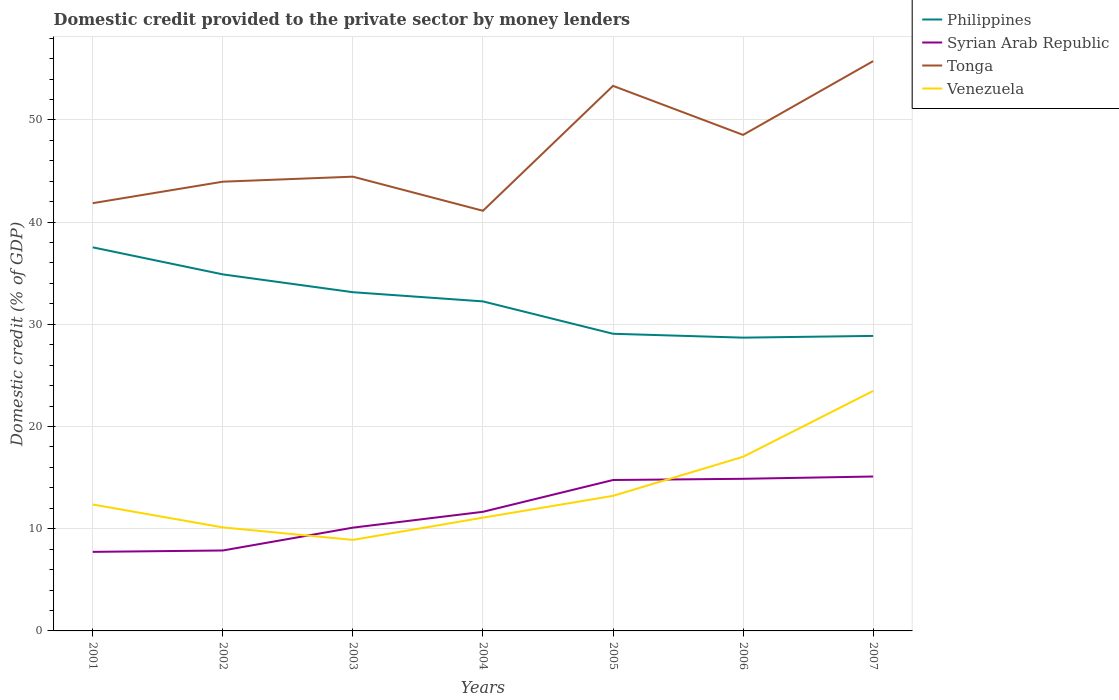Does the line corresponding to Venezuela intersect with the line corresponding to Tonga?
Ensure brevity in your answer.  No. Across all years, what is the maximum domestic credit provided to the private sector by money lenders in Venezuela?
Your answer should be very brief. 8.91. In which year was the domestic credit provided to the private sector by money lenders in Philippines maximum?
Ensure brevity in your answer.  2006. What is the total domestic credit provided to the private sector by money lenders in Tonga in the graph?
Offer a terse response. -6.68. What is the difference between the highest and the second highest domestic credit provided to the private sector by money lenders in Philippines?
Your answer should be compact. 8.84. What is the difference between the highest and the lowest domestic credit provided to the private sector by money lenders in Syrian Arab Republic?
Your answer should be compact. 3. Is the domestic credit provided to the private sector by money lenders in Tonga strictly greater than the domestic credit provided to the private sector by money lenders in Venezuela over the years?
Offer a very short reply. No. How many legend labels are there?
Your answer should be very brief. 4. What is the title of the graph?
Provide a short and direct response. Domestic credit provided to the private sector by money lenders. What is the label or title of the X-axis?
Provide a short and direct response. Years. What is the label or title of the Y-axis?
Give a very brief answer. Domestic credit (% of GDP). What is the Domestic credit (% of GDP) in Philippines in 2001?
Offer a very short reply. 37.53. What is the Domestic credit (% of GDP) of Syrian Arab Republic in 2001?
Your response must be concise. 7.74. What is the Domestic credit (% of GDP) of Tonga in 2001?
Your answer should be compact. 41.85. What is the Domestic credit (% of GDP) in Venezuela in 2001?
Provide a short and direct response. 12.37. What is the Domestic credit (% of GDP) in Philippines in 2002?
Keep it short and to the point. 34.88. What is the Domestic credit (% of GDP) of Syrian Arab Republic in 2002?
Provide a succinct answer. 7.87. What is the Domestic credit (% of GDP) of Tonga in 2002?
Make the answer very short. 43.95. What is the Domestic credit (% of GDP) in Venezuela in 2002?
Your response must be concise. 10.13. What is the Domestic credit (% of GDP) in Philippines in 2003?
Give a very brief answer. 33.14. What is the Domestic credit (% of GDP) of Syrian Arab Republic in 2003?
Ensure brevity in your answer.  10.1. What is the Domestic credit (% of GDP) in Tonga in 2003?
Offer a very short reply. 44.44. What is the Domestic credit (% of GDP) of Venezuela in 2003?
Offer a very short reply. 8.91. What is the Domestic credit (% of GDP) of Philippines in 2004?
Your response must be concise. 32.24. What is the Domestic credit (% of GDP) of Syrian Arab Republic in 2004?
Provide a short and direct response. 11.65. What is the Domestic credit (% of GDP) of Tonga in 2004?
Ensure brevity in your answer.  41.11. What is the Domestic credit (% of GDP) of Venezuela in 2004?
Your answer should be compact. 11.08. What is the Domestic credit (% of GDP) of Philippines in 2005?
Ensure brevity in your answer.  29.07. What is the Domestic credit (% of GDP) of Syrian Arab Republic in 2005?
Your response must be concise. 14.76. What is the Domestic credit (% of GDP) of Tonga in 2005?
Ensure brevity in your answer.  53.33. What is the Domestic credit (% of GDP) of Venezuela in 2005?
Keep it short and to the point. 13.21. What is the Domestic credit (% of GDP) in Philippines in 2006?
Provide a short and direct response. 28.69. What is the Domestic credit (% of GDP) in Syrian Arab Republic in 2006?
Keep it short and to the point. 14.88. What is the Domestic credit (% of GDP) in Tonga in 2006?
Keep it short and to the point. 48.53. What is the Domestic credit (% of GDP) in Venezuela in 2006?
Give a very brief answer. 17.04. What is the Domestic credit (% of GDP) in Philippines in 2007?
Your response must be concise. 28.86. What is the Domestic credit (% of GDP) in Syrian Arab Republic in 2007?
Your response must be concise. 15.11. What is the Domestic credit (% of GDP) of Tonga in 2007?
Offer a terse response. 55.75. What is the Domestic credit (% of GDP) of Venezuela in 2007?
Offer a terse response. 23.48. Across all years, what is the maximum Domestic credit (% of GDP) in Philippines?
Provide a short and direct response. 37.53. Across all years, what is the maximum Domestic credit (% of GDP) in Syrian Arab Republic?
Offer a terse response. 15.11. Across all years, what is the maximum Domestic credit (% of GDP) of Tonga?
Provide a short and direct response. 55.75. Across all years, what is the maximum Domestic credit (% of GDP) in Venezuela?
Give a very brief answer. 23.48. Across all years, what is the minimum Domestic credit (% of GDP) in Philippines?
Your answer should be compact. 28.69. Across all years, what is the minimum Domestic credit (% of GDP) in Syrian Arab Republic?
Offer a terse response. 7.74. Across all years, what is the minimum Domestic credit (% of GDP) of Tonga?
Give a very brief answer. 41.11. Across all years, what is the minimum Domestic credit (% of GDP) in Venezuela?
Provide a short and direct response. 8.91. What is the total Domestic credit (% of GDP) of Philippines in the graph?
Your response must be concise. 224.43. What is the total Domestic credit (% of GDP) in Syrian Arab Republic in the graph?
Provide a short and direct response. 82.12. What is the total Domestic credit (% of GDP) of Tonga in the graph?
Provide a short and direct response. 328.96. What is the total Domestic credit (% of GDP) in Venezuela in the graph?
Your answer should be very brief. 96.22. What is the difference between the Domestic credit (% of GDP) in Philippines in 2001 and that in 2002?
Keep it short and to the point. 2.65. What is the difference between the Domestic credit (% of GDP) in Syrian Arab Republic in 2001 and that in 2002?
Provide a succinct answer. -0.14. What is the difference between the Domestic credit (% of GDP) in Tonga in 2001 and that in 2002?
Offer a very short reply. -2.1. What is the difference between the Domestic credit (% of GDP) of Venezuela in 2001 and that in 2002?
Offer a terse response. 2.24. What is the difference between the Domestic credit (% of GDP) in Philippines in 2001 and that in 2003?
Make the answer very short. 4.39. What is the difference between the Domestic credit (% of GDP) in Syrian Arab Republic in 2001 and that in 2003?
Your response must be concise. -2.37. What is the difference between the Domestic credit (% of GDP) in Tonga in 2001 and that in 2003?
Make the answer very short. -2.59. What is the difference between the Domestic credit (% of GDP) of Venezuela in 2001 and that in 2003?
Provide a succinct answer. 3.46. What is the difference between the Domestic credit (% of GDP) in Philippines in 2001 and that in 2004?
Keep it short and to the point. 5.29. What is the difference between the Domestic credit (% of GDP) in Syrian Arab Republic in 2001 and that in 2004?
Provide a short and direct response. -3.92. What is the difference between the Domestic credit (% of GDP) of Tonga in 2001 and that in 2004?
Give a very brief answer. 0.74. What is the difference between the Domestic credit (% of GDP) of Venezuela in 2001 and that in 2004?
Make the answer very short. 1.29. What is the difference between the Domestic credit (% of GDP) in Philippines in 2001 and that in 2005?
Provide a succinct answer. 8.46. What is the difference between the Domestic credit (% of GDP) of Syrian Arab Republic in 2001 and that in 2005?
Provide a short and direct response. -7.03. What is the difference between the Domestic credit (% of GDP) of Tonga in 2001 and that in 2005?
Your answer should be very brief. -11.48. What is the difference between the Domestic credit (% of GDP) of Venezuela in 2001 and that in 2005?
Give a very brief answer. -0.84. What is the difference between the Domestic credit (% of GDP) in Philippines in 2001 and that in 2006?
Make the answer very short. 8.84. What is the difference between the Domestic credit (% of GDP) in Syrian Arab Republic in 2001 and that in 2006?
Provide a succinct answer. -7.15. What is the difference between the Domestic credit (% of GDP) in Tonga in 2001 and that in 2006?
Your answer should be compact. -6.68. What is the difference between the Domestic credit (% of GDP) of Venezuela in 2001 and that in 2006?
Give a very brief answer. -4.67. What is the difference between the Domestic credit (% of GDP) of Philippines in 2001 and that in 2007?
Offer a terse response. 8.67. What is the difference between the Domestic credit (% of GDP) of Syrian Arab Republic in 2001 and that in 2007?
Your response must be concise. -7.37. What is the difference between the Domestic credit (% of GDP) of Tonga in 2001 and that in 2007?
Keep it short and to the point. -13.9. What is the difference between the Domestic credit (% of GDP) of Venezuela in 2001 and that in 2007?
Give a very brief answer. -11.11. What is the difference between the Domestic credit (% of GDP) in Philippines in 2002 and that in 2003?
Keep it short and to the point. 1.74. What is the difference between the Domestic credit (% of GDP) of Syrian Arab Republic in 2002 and that in 2003?
Your answer should be very brief. -2.23. What is the difference between the Domestic credit (% of GDP) in Tonga in 2002 and that in 2003?
Keep it short and to the point. -0.49. What is the difference between the Domestic credit (% of GDP) in Venezuela in 2002 and that in 2003?
Keep it short and to the point. 1.22. What is the difference between the Domestic credit (% of GDP) in Philippines in 2002 and that in 2004?
Keep it short and to the point. 2.64. What is the difference between the Domestic credit (% of GDP) in Syrian Arab Republic in 2002 and that in 2004?
Ensure brevity in your answer.  -3.78. What is the difference between the Domestic credit (% of GDP) of Tonga in 2002 and that in 2004?
Offer a terse response. 2.85. What is the difference between the Domestic credit (% of GDP) of Venezuela in 2002 and that in 2004?
Your response must be concise. -0.95. What is the difference between the Domestic credit (% of GDP) in Philippines in 2002 and that in 2005?
Your response must be concise. 5.81. What is the difference between the Domestic credit (% of GDP) of Syrian Arab Republic in 2002 and that in 2005?
Your response must be concise. -6.89. What is the difference between the Domestic credit (% of GDP) in Tonga in 2002 and that in 2005?
Provide a succinct answer. -9.38. What is the difference between the Domestic credit (% of GDP) of Venezuela in 2002 and that in 2005?
Offer a very short reply. -3.09. What is the difference between the Domestic credit (% of GDP) of Philippines in 2002 and that in 2006?
Your response must be concise. 6.19. What is the difference between the Domestic credit (% of GDP) in Syrian Arab Republic in 2002 and that in 2006?
Your answer should be compact. -7.01. What is the difference between the Domestic credit (% of GDP) in Tonga in 2002 and that in 2006?
Give a very brief answer. -4.58. What is the difference between the Domestic credit (% of GDP) in Venezuela in 2002 and that in 2006?
Offer a very short reply. -6.91. What is the difference between the Domestic credit (% of GDP) of Philippines in 2002 and that in 2007?
Provide a short and direct response. 6.02. What is the difference between the Domestic credit (% of GDP) of Syrian Arab Republic in 2002 and that in 2007?
Provide a short and direct response. -7.24. What is the difference between the Domestic credit (% of GDP) in Tonga in 2002 and that in 2007?
Your answer should be compact. -11.8. What is the difference between the Domestic credit (% of GDP) in Venezuela in 2002 and that in 2007?
Your answer should be compact. -13.35. What is the difference between the Domestic credit (% of GDP) of Philippines in 2003 and that in 2004?
Give a very brief answer. 0.9. What is the difference between the Domestic credit (% of GDP) in Syrian Arab Republic in 2003 and that in 2004?
Make the answer very short. -1.55. What is the difference between the Domestic credit (% of GDP) in Tonga in 2003 and that in 2004?
Offer a very short reply. 3.34. What is the difference between the Domestic credit (% of GDP) of Venezuela in 2003 and that in 2004?
Offer a very short reply. -2.18. What is the difference between the Domestic credit (% of GDP) in Philippines in 2003 and that in 2005?
Keep it short and to the point. 4.07. What is the difference between the Domestic credit (% of GDP) of Syrian Arab Republic in 2003 and that in 2005?
Provide a short and direct response. -4.66. What is the difference between the Domestic credit (% of GDP) in Tonga in 2003 and that in 2005?
Provide a short and direct response. -8.88. What is the difference between the Domestic credit (% of GDP) in Venezuela in 2003 and that in 2005?
Make the answer very short. -4.31. What is the difference between the Domestic credit (% of GDP) of Philippines in 2003 and that in 2006?
Ensure brevity in your answer.  4.45. What is the difference between the Domestic credit (% of GDP) of Syrian Arab Republic in 2003 and that in 2006?
Provide a succinct answer. -4.78. What is the difference between the Domestic credit (% of GDP) in Tonga in 2003 and that in 2006?
Provide a succinct answer. -4.09. What is the difference between the Domestic credit (% of GDP) of Venezuela in 2003 and that in 2006?
Give a very brief answer. -8.13. What is the difference between the Domestic credit (% of GDP) in Philippines in 2003 and that in 2007?
Offer a terse response. 4.28. What is the difference between the Domestic credit (% of GDP) in Syrian Arab Republic in 2003 and that in 2007?
Make the answer very short. -5. What is the difference between the Domestic credit (% of GDP) of Tonga in 2003 and that in 2007?
Provide a short and direct response. -11.31. What is the difference between the Domestic credit (% of GDP) in Venezuela in 2003 and that in 2007?
Provide a short and direct response. -14.57. What is the difference between the Domestic credit (% of GDP) of Philippines in 2004 and that in 2005?
Keep it short and to the point. 3.17. What is the difference between the Domestic credit (% of GDP) in Syrian Arab Republic in 2004 and that in 2005?
Offer a very short reply. -3.11. What is the difference between the Domestic credit (% of GDP) in Tonga in 2004 and that in 2005?
Your answer should be compact. -12.22. What is the difference between the Domestic credit (% of GDP) of Venezuela in 2004 and that in 2005?
Provide a succinct answer. -2.13. What is the difference between the Domestic credit (% of GDP) in Philippines in 2004 and that in 2006?
Provide a succinct answer. 3.55. What is the difference between the Domestic credit (% of GDP) of Syrian Arab Republic in 2004 and that in 2006?
Ensure brevity in your answer.  -3.23. What is the difference between the Domestic credit (% of GDP) of Tonga in 2004 and that in 2006?
Give a very brief answer. -7.42. What is the difference between the Domestic credit (% of GDP) of Venezuela in 2004 and that in 2006?
Give a very brief answer. -5.96. What is the difference between the Domestic credit (% of GDP) in Philippines in 2004 and that in 2007?
Give a very brief answer. 3.38. What is the difference between the Domestic credit (% of GDP) in Syrian Arab Republic in 2004 and that in 2007?
Make the answer very short. -3.45. What is the difference between the Domestic credit (% of GDP) in Tonga in 2004 and that in 2007?
Provide a succinct answer. -14.64. What is the difference between the Domestic credit (% of GDP) of Venezuela in 2004 and that in 2007?
Keep it short and to the point. -12.4. What is the difference between the Domestic credit (% of GDP) of Philippines in 2005 and that in 2006?
Your answer should be very brief. 0.38. What is the difference between the Domestic credit (% of GDP) of Syrian Arab Republic in 2005 and that in 2006?
Your answer should be compact. -0.12. What is the difference between the Domestic credit (% of GDP) in Tonga in 2005 and that in 2006?
Your answer should be very brief. 4.8. What is the difference between the Domestic credit (% of GDP) of Venezuela in 2005 and that in 2006?
Provide a succinct answer. -3.82. What is the difference between the Domestic credit (% of GDP) in Philippines in 2005 and that in 2007?
Provide a short and direct response. 0.21. What is the difference between the Domestic credit (% of GDP) in Syrian Arab Republic in 2005 and that in 2007?
Keep it short and to the point. -0.34. What is the difference between the Domestic credit (% of GDP) of Tonga in 2005 and that in 2007?
Your answer should be compact. -2.42. What is the difference between the Domestic credit (% of GDP) in Venezuela in 2005 and that in 2007?
Provide a short and direct response. -10.27. What is the difference between the Domestic credit (% of GDP) of Philippines in 2006 and that in 2007?
Your response must be concise. -0.17. What is the difference between the Domestic credit (% of GDP) of Syrian Arab Republic in 2006 and that in 2007?
Provide a succinct answer. -0.22. What is the difference between the Domestic credit (% of GDP) of Tonga in 2006 and that in 2007?
Provide a succinct answer. -7.22. What is the difference between the Domestic credit (% of GDP) in Venezuela in 2006 and that in 2007?
Offer a very short reply. -6.44. What is the difference between the Domestic credit (% of GDP) of Philippines in 2001 and the Domestic credit (% of GDP) of Syrian Arab Republic in 2002?
Your response must be concise. 29.66. What is the difference between the Domestic credit (% of GDP) in Philippines in 2001 and the Domestic credit (% of GDP) in Tonga in 2002?
Your answer should be very brief. -6.42. What is the difference between the Domestic credit (% of GDP) of Philippines in 2001 and the Domestic credit (% of GDP) of Venezuela in 2002?
Keep it short and to the point. 27.4. What is the difference between the Domestic credit (% of GDP) in Syrian Arab Republic in 2001 and the Domestic credit (% of GDP) in Tonga in 2002?
Offer a very short reply. -36.22. What is the difference between the Domestic credit (% of GDP) of Syrian Arab Republic in 2001 and the Domestic credit (% of GDP) of Venezuela in 2002?
Provide a succinct answer. -2.39. What is the difference between the Domestic credit (% of GDP) in Tonga in 2001 and the Domestic credit (% of GDP) in Venezuela in 2002?
Provide a succinct answer. 31.72. What is the difference between the Domestic credit (% of GDP) in Philippines in 2001 and the Domestic credit (% of GDP) in Syrian Arab Republic in 2003?
Provide a succinct answer. 27.43. What is the difference between the Domestic credit (% of GDP) of Philippines in 2001 and the Domestic credit (% of GDP) of Tonga in 2003?
Your answer should be very brief. -6.91. What is the difference between the Domestic credit (% of GDP) of Philippines in 2001 and the Domestic credit (% of GDP) of Venezuela in 2003?
Your answer should be compact. 28.62. What is the difference between the Domestic credit (% of GDP) of Syrian Arab Republic in 2001 and the Domestic credit (% of GDP) of Tonga in 2003?
Provide a succinct answer. -36.71. What is the difference between the Domestic credit (% of GDP) in Syrian Arab Republic in 2001 and the Domestic credit (% of GDP) in Venezuela in 2003?
Provide a short and direct response. -1.17. What is the difference between the Domestic credit (% of GDP) of Tonga in 2001 and the Domestic credit (% of GDP) of Venezuela in 2003?
Give a very brief answer. 32.95. What is the difference between the Domestic credit (% of GDP) in Philippines in 2001 and the Domestic credit (% of GDP) in Syrian Arab Republic in 2004?
Your answer should be very brief. 25.88. What is the difference between the Domestic credit (% of GDP) of Philippines in 2001 and the Domestic credit (% of GDP) of Tonga in 2004?
Your response must be concise. -3.58. What is the difference between the Domestic credit (% of GDP) of Philippines in 2001 and the Domestic credit (% of GDP) of Venezuela in 2004?
Your answer should be compact. 26.45. What is the difference between the Domestic credit (% of GDP) in Syrian Arab Republic in 2001 and the Domestic credit (% of GDP) in Tonga in 2004?
Provide a short and direct response. -33.37. What is the difference between the Domestic credit (% of GDP) in Syrian Arab Republic in 2001 and the Domestic credit (% of GDP) in Venezuela in 2004?
Provide a short and direct response. -3.35. What is the difference between the Domestic credit (% of GDP) of Tonga in 2001 and the Domestic credit (% of GDP) of Venezuela in 2004?
Your answer should be very brief. 30.77. What is the difference between the Domestic credit (% of GDP) in Philippines in 2001 and the Domestic credit (% of GDP) in Syrian Arab Republic in 2005?
Your answer should be compact. 22.77. What is the difference between the Domestic credit (% of GDP) of Philippines in 2001 and the Domestic credit (% of GDP) of Tonga in 2005?
Provide a succinct answer. -15.8. What is the difference between the Domestic credit (% of GDP) in Philippines in 2001 and the Domestic credit (% of GDP) in Venezuela in 2005?
Provide a succinct answer. 24.31. What is the difference between the Domestic credit (% of GDP) in Syrian Arab Republic in 2001 and the Domestic credit (% of GDP) in Tonga in 2005?
Your response must be concise. -45.59. What is the difference between the Domestic credit (% of GDP) in Syrian Arab Republic in 2001 and the Domestic credit (% of GDP) in Venezuela in 2005?
Offer a very short reply. -5.48. What is the difference between the Domestic credit (% of GDP) of Tonga in 2001 and the Domestic credit (% of GDP) of Venezuela in 2005?
Provide a succinct answer. 28.64. What is the difference between the Domestic credit (% of GDP) in Philippines in 2001 and the Domestic credit (% of GDP) in Syrian Arab Republic in 2006?
Your answer should be very brief. 22.65. What is the difference between the Domestic credit (% of GDP) in Philippines in 2001 and the Domestic credit (% of GDP) in Tonga in 2006?
Offer a very short reply. -11. What is the difference between the Domestic credit (% of GDP) of Philippines in 2001 and the Domestic credit (% of GDP) of Venezuela in 2006?
Your answer should be compact. 20.49. What is the difference between the Domestic credit (% of GDP) of Syrian Arab Republic in 2001 and the Domestic credit (% of GDP) of Tonga in 2006?
Make the answer very short. -40.8. What is the difference between the Domestic credit (% of GDP) of Syrian Arab Republic in 2001 and the Domestic credit (% of GDP) of Venezuela in 2006?
Offer a very short reply. -9.3. What is the difference between the Domestic credit (% of GDP) in Tonga in 2001 and the Domestic credit (% of GDP) in Venezuela in 2006?
Provide a succinct answer. 24.81. What is the difference between the Domestic credit (% of GDP) in Philippines in 2001 and the Domestic credit (% of GDP) in Syrian Arab Republic in 2007?
Your answer should be very brief. 22.42. What is the difference between the Domestic credit (% of GDP) in Philippines in 2001 and the Domestic credit (% of GDP) in Tonga in 2007?
Make the answer very short. -18.22. What is the difference between the Domestic credit (% of GDP) in Philippines in 2001 and the Domestic credit (% of GDP) in Venezuela in 2007?
Give a very brief answer. 14.05. What is the difference between the Domestic credit (% of GDP) of Syrian Arab Republic in 2001 and the Domestic credit (% of GDP) of Tonga in 2007?
Provide a short and direct response. -48.02. What is the difference between the Domestic credit (% of GDP) of Syrian Arab Republic in 2001 and the Domestic credit (% of GDP) of Venezuela in 2007?
Offer a terse response. -15.75. What is the difference between the Domestic credit (% of GDP) of Tonga in 2001 and the Domestic credit (% of GDP) of Venezuela in 2007?
Provide a succinct answer. 18.37. What is the difference between the Domestic credit (% of GDP) in Philippines in 2002 and the Domestic credit (% of GDP) in Syrian Arab Republic in 2003?
Provide a succinct answer. 24.78. What is the difference between the Domestic credit (% of GDP) in Philippines in 2002 and the Domestic credit (% of GDP) in Tonga in 2003?
Provide a succinct answer. -9.56. What is the difference between the Domestic credit (% of GDP) in Philippines in 2002 and the Domestic credit (% of GDP) in Venezuela in 2003?
Offer a terse response. 25.98. What is the difference between the Domestic credit (% of GDP) of Syrian Arab Republic in 2002 and the Domestic credit (% of GDP) of Tonga in 2003?
Provide a succinct answer. -36.57. What is the difference between the Domestic credit (% of GDP) of Syrian Arab Republic in 2002 and the Domestic credit (% of GDP) of Venezuela in 2003?
Provide a succinct answer. -1.04. What is the difference between the Domestic credit (% of GDP) in Tonga in 2002 and the Domestic credit (% of GDP) in Venezuela in 2003?
Offer a terse response. 35.05. What is the difference between the Domestic credit (% of GDP) of Philippines in 2002 and the Domestic credit (% of GDP) of Syrian Arab Republic in 2004?
Your answer should be very brief. 23.23. What is the difference between the Domestic credit (% of GDP) of Philippines in 2002 and the Domestic credit (% of GDP) of Tonga in 2004?
Offer a very short reply. -6.22. What is the difference between the Domestic credit (% of GDP) of Philippines in 2002 and the Domestic credit (% of GDP) of Venezuela in 2004?
Provide a short and direct response. 23.8. What is the difference between the Domestic credit (% of GDP) in Syrian Arab Republic in 2002 and the Domestic credit (% of GDP) in Tonga in 2004?
Offer a very short reply. -33.24. What is the difference between the Domestic credit (% of GDP) in Syrian Arab Republic in 2002 and the Domestic credit (% of GDP) in Venezuela in 2004?
Ensure brevity in your answer.  -3.21. What is the difference between the Domestic credit (% of GDP) of Tonga in 2002 and the Domestic credit (% of GDP) of Venezuela in 2004?
Provide a succinct answer. 32.87. What is the difference between the Domestic credit (% of GDP) in Philippines in 2002 and the Domestic credit (% of GDP) in Syrian Arab Republic in 2005?
Your answer should be compact. 20.12. What is the difference between the Domestic credit (% of GDP) in Philippines in 2002 and the Domestic credit (% of GDP) in Tonga in 2005?
Give a very brief answer. -18.44. What is the difference between the Domestic credit (% of GDP) of Philippines in 2002 and the Domestic credit (% of GDP) of Venezuela in 2005?
Provide a succinct answer. 21.67. What is the difference between the Domestic credit (% of GDP) in Syrian Arab Republic in 2002 and the Domestic credit (% of GDP) in Tonga in 2005?
Provide a succinct answer. -45.46. What is the difference between the Domestic credit (% of GDP) in Syrian Arab Republic in 2002 and the Domestic credit (% of GDP) in Venezuela in 2005?
Your answer should be compact. -5.34. What is the difference between the Domestic credit (% of GDP) in Tonga in 2002 and the Domestic credit (% of GDP) in Venezuela in 2005?
Ensure brevity in your answer.  30.74. What is the difference between the Domestic credit (% of GDP) of Philippines in 2002 and the Domestic credit (% of GDP) of Syrian Arab Republic in 2006?
Keep it short and to the point. 20. What is the difference between the Domestic credit (% of GDP) of Philippines in 2002 and the Domestic credit (% of GDP) of Tonga in 2006?
Your answer should be compact. -13.65. What is the difference between the Domestic credit (% of GDP) in Philippines in 2002 and the Domestic credit (% of GDP) in Venezuela in 2006?
Offer a very short reply. 17.85. What is the difference between the Domestic credit (% of GDP) in Syrian Arab Republic in 2002 and the Domestic credit (% of GDP) in Tonga in 2006?
Ensure brevity in your answer.  -40.66. What is the difference between the Domestic credit (% of GDP) in Syrian Arab Republic in 2002 and the Domestic credit (% of GDP) in Venezuela in 2006?
Keep it short and to the point. -9.17. What is the difference between the Domestic credit (% of GDP) of Tonga in 2002 and the Domestic credit (% of GDP) of Venezuela in 2006?
Provide a succinct answer. 26.92. What is the difference between the Domestic credit (% of GDP) of Philippines in 2002 and the Domestic credit (% of GDP) of Syrian Arab Republic in 2007?
Your answer should be very brief. 19.78. What is the difference between the Domestic credit (% of GDP) of Philippines in 2002 and the Domestic credit (% of GDP) of Tonga in 2007?
Give a very brief answer. -20.87. What is the difference between the Domestic credit (% of GDP) of Philippines in 2002 and the Domestic credit (% of GDP) of Venezuela in 2007?
Your response must be concise. 11.4. What is the difference between the Domestic credit (% of GDP) in Syrian Arab Republic in 2002 and the Domestic credit (% of GDP) in Tonga in 2007?
Offer a terse response. -47.88. What is the difference between the Domestic credit (% of GDP) of Syrian Arab Republic in 2002 and the Domestic credit (% of GDP) of Venezuela in 2007?
Ensure brevity in your answer.  -15.61. What is the difference between the Domestic credit (% of GDP) of Tonga in 2002 and the Domestic credit (% of GDP) of Venezuela in 2007?
Your answer should be very brief. 20.47. What is the difference between the Domestic credit (% of GDP) in Philippines in 2003 and the Domestic credit (% of GDP) in Syrian Arab Republic in 2004?
Make the answer very short. 21.49. What is the difference between the Domestic credit (% of GDP) of Philippines in 2003 and the Domestic credit (% of GDP) of Tonga in 2004?
Give a very brief answer. -7.97. What is the difference between the Domestic credit (% of GDP) in Philippines in 2003 and the Domestic credit (% of GDP) in Venezuela in 2004?
Your answer should be compact. 22.06. What is the difference between the Domestic credit (% of GDP) in Syrian Arab Republic in 2003 and the Domestic credit (% of GDP) in Tonga in 2004?
Provide a succinct answer. -31. What is the difference between the Domestic credit (% of GDP) of Syrian Arab Republic in 2003 and the Domestic credit (% of GDP) of Venezuela in 2004?
Your response must be concise. -0.98. What is the difference between the Domestic credit (% of GDP) of Tonga in 2003 and the Domestic credit (% of GDP) of Venezuela in 2004?
Keep it short and to the point. 33.36. What is the difference between the Domestic credit (% of GDP) of Philippines in 2003 and the Domestic credit (% of GDP) of Syrian Arab Republic in 2005?
Make the answer very short. 18.38. What is the difference between the Domestic credit (% of GDP) in Philippines in 2003 and the Domestic credit (% of GDP) in Tonga in 2005?
Your response must be concise. -20.19. What is the difference between the Domestic credit (% of GDP) in Philippines in 2003 and the Domestic credit (% of GDP) in Venezuela in 2005?
Offer a very short reply. 19.93. What is the difference between the Domestic credit (% of GDP) in Syrian Arab Republic in 2003 and the Domestic credit (% of GDP) in Tonga in 2005?
Keep it short and to the point. -43.22. What is the difference between the Domestic credit (% of GDP) of Syrian Arab Republic in 2003 and the Domestic credit (% of GDP) of Venezuela in 2005?
Your response must be concise. -3.11. What is the difference between the Domestic credit (% of GDP) of Tonga in 2003 and the Domestic credit (% of GDP) of Venezuela in 2005?
Keep it short and to the point. 31.23. What is the difference between the Domestic credit (% of GDP) of Philippines in 2003 and the Domestic credit (% of GDP) of Syrian Arab Republic in 2006?
Keep it short and to the point. 18.26. What is the difference between the Domestic credit (% of GDP) of Philippines in 2003 and the Domestic credit (% of GDP) of Tonga in 2006?
Ensure brevity in your answer.  -15.39. What is the difference between the Domestic credit (% of GDP) of Philippines in 2003 and the Domestic credit (% of GDP) of Venezuela in 2006?
Your response must be concise. 16.1. What is the difference between the Domestic credit (% of GDP) of Syrian Arab Republic in 2003 and the Domestic credit (% of GDP) of Tonga in 2006?
Your response must be concise. -38.43. What is the difference between the Domestic credit (% of GDP) of Syrian Arab Republic in 2003 and the Domestic credit (% of GDP) of Venezuela in 2006?
Your response must be concise. -6.93. What is the difference between the Domestic credit (% of GDP) of Tonga in 2003 and the Domestic credit (% of GDP) of Venezuela in 2006?
Keep it short and to the point. 27.41. What is the difference between the Domestic credit (% of GDP) of Philippines in 2003 and the Domestic credit (% of GDP) of Syrian Arab Republic in 2007?
Provide a short and direct response. 18.03. What is the difference between the Domestic credit (% of GDP) of Philippines in 2003 and the Domestic credit (% of GDP) of Tonga in 2007?
Provide a succinct answer. -22.61. What is the difference between the Domestic credit (% of GDP) in Philippines in 2003 and the Domestic credit (% of GDP) in Venezuela in 2007?
Make the answer very short. 9.66. What is the difference between the Domestic credit (% of GDP) of Syrian Arab Republic in 2003 and the Domestic credit (% of GDP) of Tonga in 2007?
Provide a succinct answer. -45.65. What is the difference between the Domestic credit (% of GDP) of Syrian Arab Republic in 2003 and the Domestic credit (% of GDP) of Venezuela in 2007?
Your response must be concise. -13.38. What is the difference between the Domestic credit (% of GDP) in Tonga in 2003 and the Domestic credit (% of GDP) in Venezuela in 2007?
Provide a succinct answer. 20.96. What is the difference between the Domestic credit (% of GDP) of Philippines in 2004 and the Domestic credit (% of GDP) of Syrian Arab Republic in 2005?
Keep it short and to the point. 17.48. What is the difference between the Domestic credit (% of GDP) in Philippines in 2004 and the Domestic credit (% of GDP) in Tonga in 2005?
Provide a succinct answer. -21.09. What is the difference between the Domestic credit (% of GDP) in Philippines in 2004 and the Domestic credit (% of GDP) in Venezuela in 2005?
Keep it short and to the point. 19.03. What is the difference between the Domestic credit (% of GDP) of Syrian Arab Republic in 2004 and the Domestic credit (% of GDP) of Tonga in 2005?
Your answer should be very brief. -41.67. What is the difference between the Domestic credit (% of GDP) in Syrian Arab Republic in 2004 and the Domestic credit (% of GDP) in Venezuela in 2005?
Offer a terse response. -1.56. What is the difference between the Domestic credit (% of GDP) of Tonga in 2004 and the Domestic credit (% of GDP) of Venezuela in 2005?
Offer a terse response. 27.89. What is the difference between the Domestic credit (% of GDP) of Philippines in 2004 and the Domestic credit (% of GDP) of Syrian Arab Republic in 2006?
Provide a short and direct response. 17.36. What is the difference between the Domestic credit (% of GDP) of Philippines in 2004 and the Domestic credit (% of GDP) of Tonga in 2006?
Keep it short and to the point. -16.29. What is the difference between the Domestic credit (% of GDP) of Philippines in 2004 and the Domestic credit (% of GDP) of Venezuela in 2006?
Offer a very short reply. 15.2. What is the difference between the Domestic credit (% of GDP) of Syrian Arab Republic in 2004 and the Domestic credit (% of GDP) of Tonga in 2006?
Offer a very short reply. -36.88. What is the difference between the Domestic credit (% of GDP) of Syrian Arab Republic in 2004 and the Domestic credit (% of GDP) of Venezuela in 2006?
Your answer should be compact. -5.38. What is the difference between the Domestic credit (% of GDP) of Tonga in 2004 and the Domestic credit (% of GDP) of Venezuela in 2006?
Your answer should be very brief. 24.07. What is the difference between the Domestic credit (% of GDP) in Philippines in 2004 and the Domestic credit (% of GDP) in Syrian Arab Republic in 2007?
Offer a terse response. 17.13. What is the difference between the Domestic credit (% of GDP) of Philippines in 2004 and the Domestic credit (% of GDP) of Tonga in 2007?
Give a very brief answer. -23.51. What is the difference between the Domestic credit (% of GDP) of Philippines in 2004 and the Domestic credit (% of GDP) of Venezuela in 2007?
Offer a very short reply. 8.76. What is the difference between the Domestic credit (% of GDP) of Syrian Arab Republic in 2004 and the Domestic credit (% of GDP) of Tonga in 2007?
Offer a very short reply. -44.1. What is the difference between the Domestic credit (% of GDP) in Syrian Arab Republic in 2004 and the Domestic credit (% of GDP) in Venezuela in 2007?
Provide a succinct answer. -11.83. What is the difference between the Domestic credit (% of GDP) in Tonga in 2004 and the Domestic credit (% of GDP) in Venezuela in 2007?
Ensure brevity in your answer.  17.63. What is the difference between the Domestic credit (% of GDP) of Philippines in 2005 and the Domestic credit (% of GDP) of Syrian Arab Republic in 2006?
Give a very brief answer. 14.19. What is the difference between the Domestic credit (% of GDP) of Philippines in 2005 and the Domestic credit (% of GDP) of Tonga in 2006?
Your answer should be very brief. -19.46. What is the difference between the Domestic credit (% of GDP) of Philippines in 2005 and the Domestic credit (% of GDP) of Venezuela in 2006?
Keep it short and to the point. 12.04. What is the difference between the Domestic credit (% of GDP) of Syrian Arab Republic in 2005 and the Domestic credit (% of GDP) of Tonga in 2006?
Ensure brevity in your answer.  -33.77. What is the difference between the Domestic credit (% of GDP) in Syrian Arab Republic in 2005 and the Domestic credit (% of GDP) in Venezuela in 2006?
Give a very brief answer. -2.27. What is the difference between the Domestic credit (% of GDP) of Tonga in 2005 and the Domestic credit (% of GDP) of Venezuela in 2006?
Offer a very short reply. 36.29. What is the difference between the Domestic credit (% of GDP) of Philippines in 2005 and the Domestic credit (% of GDP) of Syrian Arab Republic in 2007?
Offer a very short reply. 13.97. What is the difference between the Domestic credit (% of GDP) of Philippines in 2005 and the Domestic credit (% of GDP) of Tonga in 2007?
Offer a very short reply. -26.68. What is the difference between the Domestic credit (% of GDP) of Philippines in 2005 and the Domestic credit (% of GDP) of Venezuela in 2007?
Keep it short and to the point. 5.59. What is the difference between the Domestic credit (% of GDP) of Syrian Arab Republic in 2005 and the Domestic credit (% of GDP) of Tonga in 2007?
Keep it short and to the point. -40.99. What is the difference between the Domestic credit (% of GDP) in Syrian Arab Republic in 2005 and the Domestic credit (% of GDP) in Venezuela in 2007?
Provide a short and direct response. -8.72. What is the difference between the Domestic credit (% of GDP) of Tonga in 2005 and the Domestic credit (% of GDP) of Venezuela in 2007?
Keep it short and to the point. 29.85. What is the difference between the Domestic credit (% of GDP) of Philippines in 2006 and the Domestic credit (% of GDP) of Syrian Arab Republic in 2007?
Offer a very short reply. 13.59. What is the difference between the Domestic credit (% of GDP) of Philippines in 2006 and the Domestic credit (% of GDP) of Tonga in 2007?
Provide a short and direct response. -27.06. What is the difference between the Domestic credit (% of GDP) in Philippines in 2006 and the Domestic credit (% of GDP) in Venezuela in 2007?
Ensure brevity in your answer.  5.21. What is the difference between the Domestic credit (% of GDP) of Syrian Arab Republic in 2006 and the Domestic credit (% of GDP) of Tonga in 2007?
Your response must be concise. -40.87. What is the difference between the Domestic credit (% of GDP) of Syrian Arab Republic in 2006 and the Domestic credit (% of GDP) of Venezuela in 2007?
Provide a short and direct response. -8.6. What is the difference between the Domestic credit (% of GDP) of Tonga in 2006 and the Domestic credit (% of GDP) of Venezuela in 2007?
Keep it short and to the point. 25.05. What is the average Domestic credit (% of GDP) of Philippines per year?
Your answer should be compact. 32.06. What is the average Domestic credit (% of GDP) in Syrian Arab Republic per year?
Your answer should be very brief. 11.73. What is the average Domestic credit (% of GDP) in Tonga per year?
Ensure brevity in your answer.  46.99. What is the average Domestic credit (% of GDP) in Venezuela per year?
Your answer should be very brief. 13.75. In the year 2001, what is the difference between the Domestic credit (% of GDP) of Philippines and Domestic credit (% of GDP) of Syrian Arab Republic?
Provide a short and direct response. 29.79. In the year 2001, what is the difference between the Domestic credit (% of GDP) in Philippines and Domestic credit (% of GDP) in Tonga?
Keep it short and to the point. -4.32. In the year 2001, what is the difference between the Domestic credit (% of GDP) of Philippines and Domestic credit (% of GDP) of Venezuela?
Offer a terse response. 25.16. In the year 2001, what is the difference between the Domestic credit (% of GDP) of Syrian Arab Republic and Domestic credit (% of GDP) of Tonga?
Give a very brief answer. -34.12. In the year 2001, what is the difference between the Domestic credit (% of GDP) in Syrian Arab Republic and Domestic credit (% of GDP) in Venezuela?
Ensure brevity in your answer.  -4.63. In the year 2001, what is the difference between the Domestic credit (% of GDP) in Tonga and Domestic credit (% of GDP) in Venezuela?
Ensure brevity in your answer.  29.48. In the year 2002, what is the difference between the Domestic credit (% of GDP) of Philippines and Domestic credit (% of GDP) of Syrian Arab Republic?
Keep it short and to the point. 27.01. In the year 2002, what is the difference between the Domestic credit (% of GDP) in Philippines and Domestic credit (% of GDP) in Tonga?
Give a very brief answer. -9.07. In the year 2002, what is the difference between the Domestic credit (% of GDP) of Philippines and Domestic credit (% of GDP) of Venezuela?
Make the answer very short. 24.76. In the year 2002, what is the difference between the Domestic credit (% of GDP) in Syrian Arab Republic and Domestic credit (% of GDP) in Tonga?
Provide a short and direct response. -36.08. In the year 2002, what is the difference between the Domestic credit (% of GDP) of Syrian Arab Republic and Domestic credit (% of GDP) of Venezuela?
Ensure brevity in your answer.  -2.26. In the year 2002, what is the difference between the Domestic credit (% of GDP) of Tonga and Domestic credit (% of GDP) of Venezuela?
Offer a terse response. 33.83. In the year 2003, what is the difference between the Domestic credit (% of GDP) in Philippines and Domestic credit (% of GDP) in Syrian Arab Republic?
Your response must be concise. 23.04. In the year 2003, what is the difference between the Domestic credit (% of GDP) of Philippines and Domestic credit (% of GDP) of Tonga?
Offer a terse response. -11.3. In the year 2003, what is the difference between the Domestic credit (% of GDP) of Philippines and Domestic credit (% of GDP) of Venezuela?
Your answer should be very brief. 24.23. In the year 2003, what is the difference between the Domestic credit (% of GDP) of Syrian Arab Republic and Domestic credit (% of GDP) of Tonga?
Provide a succinct answer. -34.34. In the year 2003, what is the difference between the Domestic credit (% of GDP) of Syrian Arab Republic and Domestic credit (% of GDP) of Venezuela?
Your answer should be compact. 1.2. In the year 2003, what is the difference between the Domestic credit (% of GDP) of Tonga and Domestic credit (% of GDP) of Venezuela?
Provide a short and direct response. 35.54. In the year 2004, what is the difference between the Domestic credit (% of GDP) in Philippines and Domestic credit (% of GDP) in Syrian Arab Republic?
Your response must be concise. 20.59. In the year 2004, what is the difference between the Domestic credit (% of GDP) in Philippines and Domestic credit (% of GDP) in Tonga?
Provide a short and direct response. -8.87. In the year 2004, what is the difference between the Domestic credit (% of GDP) of Philippines and Domestic credit (% of GDP) of Venezuela?
Your answer should be compact. 21.16. In the year 2004, what is the difference between the Domestic credit (% of GDP) of Syrian Arab Republic and Domestic credit (% of GDP) of Tonga?
Keep it short and to the point. -29.45. In the year 2004, what is the difference between the Domestic credit (% of GDP) in Syrian Arab Republic and Domestic credit (% of GDP) in Venezuela?
Ensure brevity in your answer.  0.57. In the year 2004, what is the difference between the Domestic credit (% of GDP) of Tonga and Domestic credit (% of GDP) of Venezuela?
Make the answer very short. 30.02. In the year 2005, what is the difference between the Domestic credit (% of GDP) in Philippines and Domestic credit (% of GDP) in Syrian Arab Republic?
Offer a terse response. 14.31. In the year 2005, what is the difference between the Domestic credit (% of GDP) of Philippines and Domestic credit (% of GDP) of Tonga?
Your answer should be compact. -24.26. In the year 2005, what is the difference between the Domestic credit (% of GDP) in Philippines and Domestic credit (% of GDP) in Venezuela?
Offer a terse response. 15.86. In the year 2005, what is the difference between the Domestic credit (% of GDP) of Syrian Arab Republic and Domestic credit (% of GDP) of Tonga?
Ensure brevity in your answer.  -38.56. In the year 2005, what is the difference between the Domestic credit (% of GDP) in Syrian Arab Republic and Domestic credit (% of GDP) in Venezuela?
Ensure brevity in your answer.  1.55. In the year 2005, what is the difference between the Domestic credit (% of GDP) in Tonga and Domestic credit (% of GDP) in Venezuela?
Ensure brevity in your answer.  40.11. In the year 2006, what is the difference between the Domestic credit (% of GDP) of Philippines and Domestic credit (% of GDP) of Syrian Arab Republic?
Give a very brief answer. 13.81. In the year 2006, what is the difference between the Domestic credit (% of GDP) of Philippines and Domestic credit (% of GDP) of Tonga?
Provide a short and direct response. -19.84. In the year 2006, what is the difference between the Domestic credit (% of GDP) in Philippines and Domestic credit (% of GDP) in Venezuela?
Offer a very short reply. 11.66. In the year 2006, what is the difference between the Domestic credit (% of GDP) of Syrian Arab Republic and Domestic credit (% of GDP) of Tonga?
Provide a succinct answer. -33.65. In the year 2006, what is the difference between the Domestic credit (% of GDP) of Syrian Arab Republic and Domestic credit (% of GDP) of Venezuela?
Your answer should be compact. -2.15. In the year 2006, what is the difference between the Domestic credit (% of GDP) of Tonga and Domestic credit (% of GDP) of Venezuela?
Your answer should be very brief. 31.49. In the year 2007, what is the difference between the Domestic credit (% of GDP) of Philippines and Domestic credit (% of GDP) of Syrian Arab Republic?
Ensure brevity in your answer.  13.76. In the year 2007, what is the difference between the Domestic credit (% of GDP) of Philippines and Domestic credit (% of GDP) of Tonga?
Offer a very short reply. -26.89. In the year 2007, what is the difference between the Domestic credit (% of GDP) of Philippines and Domestic credit (% of GDP) of Venezuela?
Provide a succinct answer. 5.38. In the year 2007, what is the difference between the Domestic credit (% of GDP) in Syrian Arab Republic and Domestic credit (% of GDP) in Tonga?
Give a very brief answer. -40.64. In the year 2007, what is the difference between the Domestic credit (% of GDP) of Syrian Arab Republic and Domestic credit (% of GDP) of Venezuela?
Keep it short and to the point. -8.37. In the year 2007, what is the difference between the Domestic credit (% of GDP) in Tonga and Domestic credit (% of GDP) in Venezuela?
Make the answer very short. 32.27. What is the ratio of the Domestic credit (% of GDP) of Philippines in 2001 to that in 2002?
Your answer should be very brief. 1.08. What is the ratio of the Domestic credit (% of GDP) in Syrian Arab Republic in 2001 to that in 2002?
Provide a short and direct response. 0.98. What is the ratio of the Domestic credit (% of GDP) in Tonga in 2001 to that in 2002?
Your answer should be very brief. 0.95. What is the ratio of the Domestic credit (% of GDP) of Venezuela in 2001 to that in 2002?
Your response must be concise. 1.22. What is the ratio of the Domestic credit (% of GDP) in Philippines in 2001 to that in 2003?
Provide a short and direct response. 1.13. What is the ratio of the Domestic credit (% of GDP) in Syrian Arab Republic in 2001 to that in 2003?
Provide a succinct answer. 0.77. What is the ratio of the Domestic credit (% of GDP) of Tonga in 2001 to that in 2003?
Offer a terse response. 0.94. What is the ratio of the Domestic credit (% of GDP) in Venezuela in 2001 to that in 2003?
Provide a succinct answer. 1.39. What is the ratio of the Domestic credit (% of GDP) of Philippines in 2001 to that in 2004?
Keep it short and to the point. 1.16. What is the ratio of the Domestic credit (% of GDP) of Syrian Arab Republic in 2001 to that in 2004?
Offer a very short reply. 0.66. What is the ratio of the Domestic credit (% of GDP) in Tonga in 2001 to that in 2004?
Offer a terse response. 1.02. What is the ratio of the Domestic credit (% of GDP) of Venezuela in 2001 to that in 2004?
Your answer should be very brief. 1.12. What is the ratio of the Domestic credit (% of GDP) in Philippines in 2001 to that in 2005?
Provide a short and direct response. 1.29. What is the ratio of the Domestic credit (% of GDP) in Syrian Arab Republic in 2001 to that in 2005?
Give a very brief answer. 0.52. What is the ratio of the Domestic credit (% of GDP) in Tonga in 2001 to that in 2005?
Offer a very short reply. 0.78. What is the ratio of the Domestic credit (% of GDP) of Venezuela in 2001 to that in 2005?
Your response must be concise. 0.94. What is the ratio of the Domestic credit (% of GDP) in Philippines in 2001 to that in 2006?
Ensure brevity in your answer.  1.31. What is the ratio of the Domestic credit (% of GDP) in Syrian Arab Republic in 2001 to that in 2006?
Keep it short and to the point. 0.52. What is the ratio of the Domestic credit (% of GDP) of Tonga in 2001 to that in 2006?
Provide a short and direct response. 0.86. What is the ratio of the Domestic credit (% of GDP) of Venezuela in 2001 to that in 2006?
Give a very brief answer. 0.73. What is the ratio of the Domestic credit (% of GDP) in Philippines in 2001 to that in 2007?
Ensure brevity in your answer.  1.3. What is the ratio of the Domestic credit (% of GDP) of Syrian Arab Republic in 2001 to that in 2007?
Your answer should be compact. 0.51. What is the ratio of the Domestic credit (% of GDP) of Tonga in 2001 to that in 2007?
Keep it short and to the point. 0.75. What is the ratio of the Domestic credit (% of GDP) in Venezuela in 2001 to that in 2007?
Make the answer very short. 0.53. What is the ratio of the Domestic credit (% of GDP) of Philippines in 2002 to that in 2003?
Offer a very short reply. 1.05. What is the ratio of the Domestic credit (% of GDP) of Syrian Arab Republic in 2002 to that in 2003?
Provide a short and direct response. 0.78. What is the ratio of the Domestic credit (% of GDP) in Tonga in 2002 to that in 2003?
Your answer should be very brief. 0.99. What is the ratio of the Domestic credit (% of GDP) of Venezuela in 2002 to that in 2003?
Provide a succinct answer. 1.14. What is the ratio of the Domestic credit (% of GDP) in Philippines in 2002 to that in 2004?
Ensure brevity in your answer.  1.08. What is the ratio of the Domestic credit (% of GDP) in Syrian Arab Republic in 2002 to that in 2004?
Provide a succinct answer. 0.68. What is the ratio of the Domestic credit (% of GDP) in Tonga in 2002 to that in 2004?
Give a very brief answer. 1.07. What is the ratio of the Domestic credit (% of GDP) of Venezuela in 2002 to that in 2004?
Provide a short and direct response. 0.91. What is the ratio of the Domestic credit (% of GDP) in Philippines in 2002 to that in 2005?
Provide a short and direct response. 1.2. What is the ratio of the Domestic credit (% of GDP) of Syrian Arab Republic in 2002 to that in 2005?
Provide a succinct answer. 0.53. What is the ratio of the Domestic credit (% of GDP) of Tonga in 2002 to that in 2005?
Make the answer very short. 0.82. What is the ratio of the Domestic credit (% of GDP) in Venezuela in 2002 to that in 2005?
Make the answer very short. 0.77. What is the ratio of the Domestic credit (% of GDP) in Philippines in 2002 to that in 2006?
Make the answer very short. 1.22. What is the ratio of the Domestic credit (% of GDP) in Syrian Arab Republic in 2002 to that in 2006?
Keep it short and to the point. 0.53. What is the ratio of the Domestic credit (% of GDP) in Tonga in 2002 to that in 2006?
Your response must be concise. 0.91. What is the ratio of the Domestic credit (% of GDP) of Venezuela in 2002 to that in 2006?
Keep it short and to the point. 0.59. What is the ratio of the Domestic credit (% of GDP) in Philippines in 2002 to that in 2007?
Ensure brevity in your answer.  1.21. What is the ratio of the Domestic credit (% of GDP) of Syrian Arab Republic in 2002 to that in 2007?
Offer a very short reply. 0.52. What is the ratio of the Domestic credit (% of GDP) in Tonga in 2002 to that in 2007?
Your answer should be compact. 0.79. What is the ratio of the Domestic credit (% of GDP) of Venezuela in 2002 to that in 2007?
Your response must be concise. 0.43. What is the ratio of the Domestic credit (% of GDP) in Philippines in 2003 to that in 2004?
Offer a very short reply. 1.03. What is the ratio of the Domestic credit (% of GDP) of Syrian Arab Republic in 2003 to that in 2004?
Offer a terse response. 0.87. What is the ratio of the Domestic credit (% of GDP) of Tonga in 2003 to that in 2004?
Your answer should be very brief. 1.08. What is the ratio of the Domestic credit (% of GDP) of Venezuela in 2003 to that in 2004?
Your response must be concise. 0.8. What is the ratio of the Domestic credit (% of GDP) in Philippines in 2003 to that in 2005?
Ensure brevity in your answer.  1.14. What is the ratio of the Domestic credit (% of GDP) of Syrian Arab Republic in 2003 to that in 2005?
Offer a terse response. 0.68. What is the ratio of the Domestic credit (% of GDP) of Tonga in 2003 to that in 2005?
Give a very brief answer. 0.83. What is the ratio of the Domestic credit (% of GDP) in Venezuela in 2003 to that in 2005?
Keep it short and to the point. 0.67. What is the ratio of the Domestic credit (% of GDP) in Philippines in 2003 to that in 2006?
Offer a terse response. 1.16. What is the ratio of the Domestic credit (% of GDP) of Syrian Arab Republic in 2003 to that in 2006?
Offer a very short reply. 0.68. What is the ratio of the Domestic credit (% of GDP) in Tonga in 2003 to that in 2006?
Provide a succinct answer. 0.92. What is the ratio of the Domestic credit (% of GDP) of Venezuela in 2003 to that in 2006?
Offer a very short reply. 0.52. What is the ratio of the Domestic credit (% of GDP) in Philippines in 2003 to that in 2007?
Ensure brevity in your answer.  1.15. What is the ratio of the Domestic credit (% of GDP) in Syrian Arab Republic in 2003 to that in 2007?
Your answer should be compact. 0.67. What is the ratio of the Domestic credit (% of GDP) of Tonga in 2003 to that in 2007?
Make the answer very short. 0.8. What is the ratio of the Domestic credit (% of GDP) of Venezuela in 2003 to that in 2007?
Offer a very short reply. 0.38. What is the ratio of the Domestic credit (% of GDP) in Philippines in 2004 to that in 2005?
Your answer should be very brief. 1.11. What is the ratio of the Domestic credit (% of GDP) in Syrian Arab Republic in 2004 to that in 2005?
Your response must be concise. 0.79. What is the ratio of the Domestic credit (% of GDP) of Tonga in 2004 to that in 2005?
Your response must be concise. 0.77. What is the ratio of the Domestic credit (% of GDP) of Venezuela in 2004 to that in 2005?
Your response must be concise. 0.84. What is the ratio of the Domestic credit (% of GDP) of Philippines in 2004 to that in 2006?
Keep it short and to the point. 1.12. What is the ratio of the Domestic credit (% of GDP) of Syrian Arab Republic in 2004 to that in 2006?
Ensure brevity in your answer.  0.78. What is the ratio of the Domestic credit (% of GDP) of Tonga in 2004 to that in 2006?
Keep it short and to the point. 0.85. What is the ratio of the Domestic credit (% of GDP) in Venezuela in 2004 to that in 2006?
Your answer should be compact. 0.65. What is the ratio of the Domestic credit (% of GDP) of Philippines in 2004 to that in 2007?
Give a very brief answer. 1.12. What is the ratio of the Domestic credit (% of GDP) in Syrian Arab Republic in 2004 to that in 2007?
Make the answer very short. 0.77. What is the ratio of the Domestic credit (% of GDP) in Tonga in 2004 to that in 2007?
Your answer should be very brief. 0.74. What is the ratio of the Domestic credit (% of GDP) of Venezuela in 2004 to that in 2007?
Give a very brief answer. 0.47. What is the ratio of the Domestic credit (% of GDP) in Philippines in 2005 to that in 2006?
Make the answer very short. 1.01. What is the ratio of the Domestic credit (% of GDP) in Syrian Arab Republic in 2005 to that in 2006?
Provide a short and direct response. 0.99. What is the ratio of the Domestic credit (% of GDP) in Tonga in 2005 to that in 2006?
Offer a terse response. 1.1. What is the ratio of the Domestic credit (% of GDP) of Venezuela in 2005 to that in 2006?
Offer a terse response. 0.78. What is the ratio of the Domestic credit (% of GDP) in Philippines in 2005 to that in 2007?
Provide a short and direct response. 1.01. What is the ratio of the Domestic credit (% of GDP) in Syrian Arab Republic in 2005 to that in 2007?
Ensure brevity in your answer.  0.98. What is the ratio of the Domestic credit (% of GDP) of Tonga in 2005 to that in 2007?
Provide a succinct answer. 0.96. What is the ratio of the Domestic credit (% of GDP) of Venezuela in 2005 to that in 2007?
Your answer should be compact. 0.56. What is the ratio of the Domestic credit (% of GDP) in Syrian Arab Republic in 2006 to that in 2007?
Provide a short and direct response. 0.99. What is the ratio of the Domestic credit (% of GDP) in Tonga in 2006 to that in 2007?
Your answer should be very brief. 0.87. What is the ratio of the Domestic credit (% of GDP) in Venezuela in 2006 to that in 2007?
Give a very brief answer. 0.73. What is the difference between the highest and the second highest Domestic credit (% of GDP) in Philippines?
Ensure brevity in your answer.  2.65. What is the difference between the highest and the second highest Domestic credit (% of GDP) in Syrian Arab Republic?
Offer a very short reply. 0.22. What is the difference between the highest and the second highest Domestic credit (% of GDP) of Tonga?
Ensure brevity in your answer.  2.42. What is the difference between the highest and the second highest Domestic credit (% of GDP) in Venezuela?
Offer a very short reply. 6.44. What is the difference between the highest and the lowest Domestic credit (% of GDP) of Philippines?
Your answer should be very brief. 8.84. What is the difference between the highest and the lowest Domestic credit (% of GDP) of Syrian Arab Republic?
Your response must be concise. 7.37. What is the difference between the highest and the lowest Domestic credit (% of GDP) in Tonga?
Offer a terse response. 14.64. What is the difference between the highest and the lowest Domestic credit (% of GDP) of Venezuela?
Your answer should be compact. 14.57. 